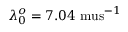<formula> <loc_0><loc_0><loc_500><loc_500>\lambda _ { 0 } ^ { o } = 7 . 0 4 \ m u s ^ { - 1 }</formula> 